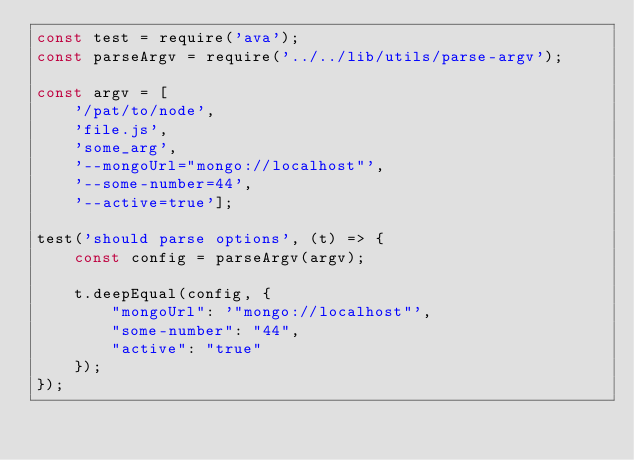Convert code to text. <code><loc_0><loc_0><loc_500><loc_500><_JavaScript_>const test = require('ava');
const parseArgv = require('../../lib/utils/parse-argv');

const argv = [
    '/pat/to/node', 
    'file.js', 
    'some_arg', 
    '--mongoUrl="mongo://localhost"',
    '--some-number=44',
    '--active=true'];

test('should parse options', (t) => {
    const config = parseArgv(argv);

    t.deepEqual(config, {
        "mongoUrl": '"mongo://localhost"',
        "some-number": "44",
        "active": "true"
    });
});</code> 